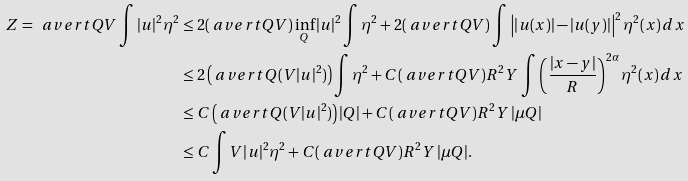Convert formula to latex. <formula><loc_0><loc_0><loc_500><loc_500>Z = \ a v e r t { Q } V \int | u | ^ { 2 } \eta ^ { 2 } & \leq 2 ( \ a v e r t { Q } V ) \inf _ { Q } | u | ^ { 2 } \int \eta ^ { 2 } + 2 ( \ a v e r t { Q } V ) \int \left | | u ( x ) | - | u ( y ) | \right | ^ { 2 } \eta ^ { 2 } ( x ) \, d x \\ & \leq 2 \left ( \ a v e r t { Q } ( V | u | ^ { 2 } ) \right ) \int \eta ^ { 2 } + C ( \ a v e r t { Q } V ) R ^ { 2 } Y \, \int \left ( \frac { | x - y | } R \right ) ^ { 2 \alpha } \eta ^ { 2 } ( x ) \, d x \\ & \leq C \left ( \ a v e r t { Q } ( V | u | ^ { 2 } ) \right ) | Q | + C ( \ a v e r t { Q } V ) R ^ { 2 } Y \, | \mu Q | \\ & \leq C \int V | u | ^ { 2 } \eta ^ { 2 } + C ( \ a v e r t { Q } V ) R ^ { 2 } Y \, | \mu Q | .</formula> 